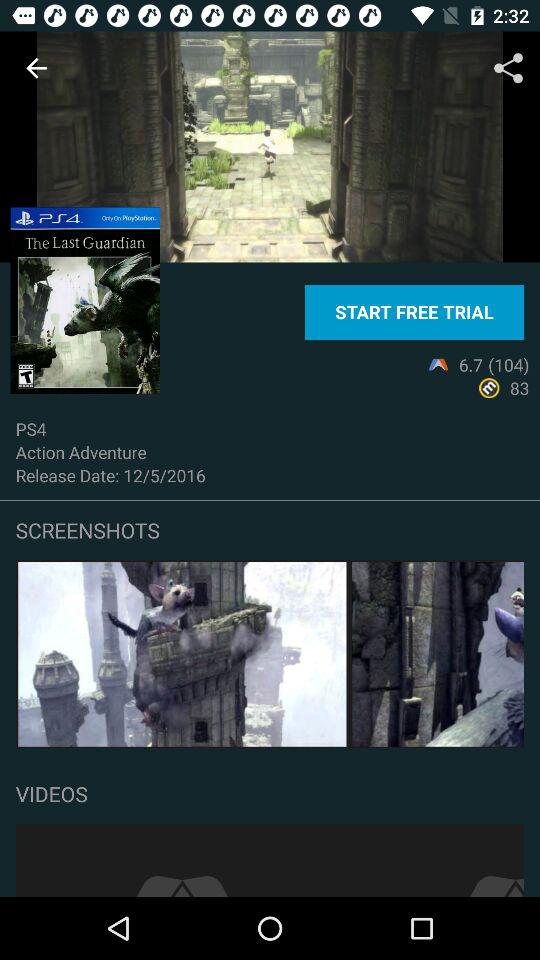What is the release date of "The Last Guardian" for PS4? The release date is May 12, 2016. 